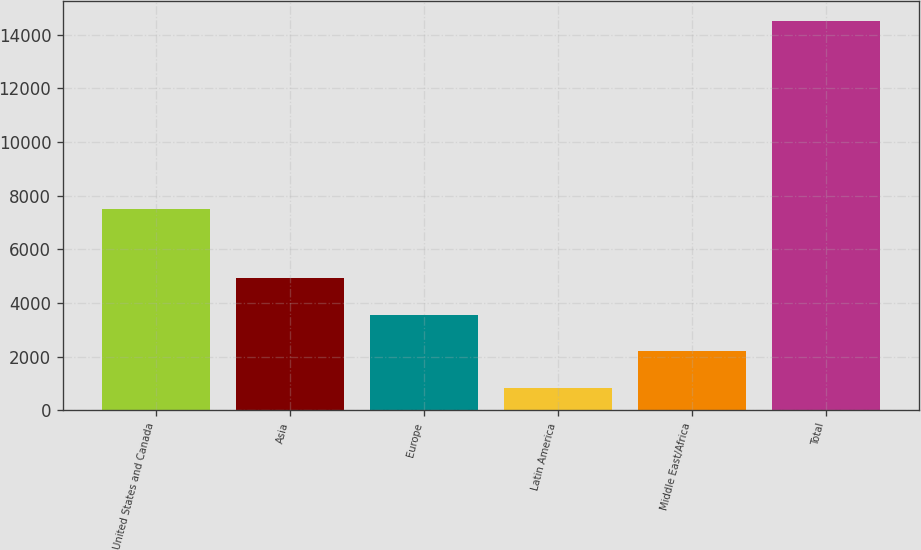Convert chart. <chart><loc_0><loc_0><loc_500><loc_500><bar_chart><fcel>United States and Canada<fcel>Asia<fcel>Europe<fcel>Latin America<fcel>Middle East/Africa<fcel>Total<nl><fcel>7505<fcel>4940.4<fcel>3571.6<fcel>834<fcel>2202.8<fcel>14522<nl></chart> 